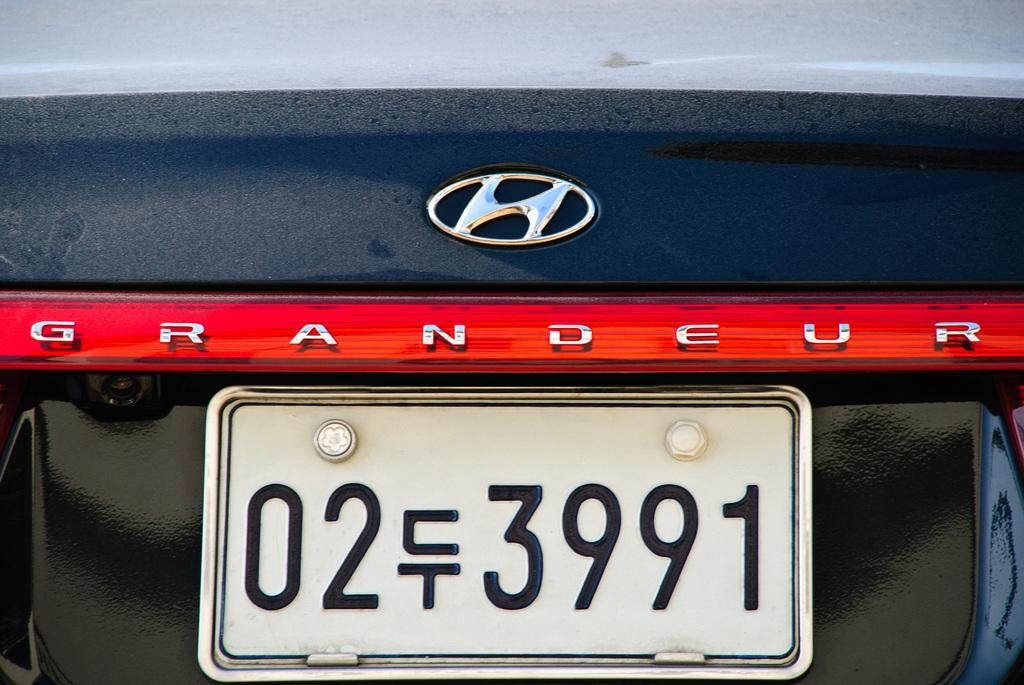Provide a one-sentence caption for the provided image. A navy blue Hyundai Grandeur has a black and white license plate. 